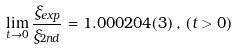Convert formula to latex. <formula><loc_0><loc_0><loc_500><loc_500>\lim _ { t \rightarrow 0 } \frac { \xi _ { e x p } } { \xi _ { 2 n d } } = 1 . 0 0 0 2 0 4 ( 3 ) \, , \, ( t > 0 ) \,</formula> 